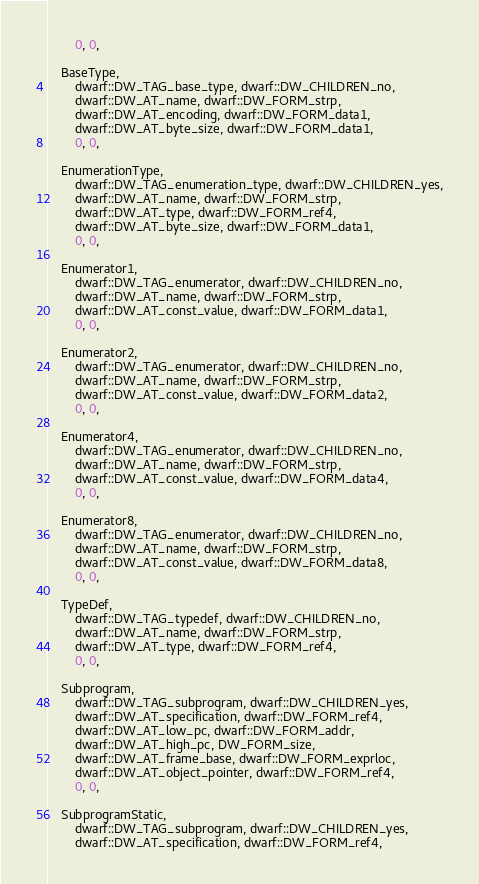<code> <loc_0><loc_0><loc_500><loc_500><_C++_>        0, 0,

    BaseType,
        dwarf::DW_TAG_base_type, dwarf::DW_CHILDREN_no,
        dwarf::DW_AT_name, dwarf::DW_FORM_strp,
        dwarf::DW_AT_encoding, dwarf::DW_FORM_data1,
        dwarf::DW_AT_byte_size, dwarf::DW_FORM_data1,
        0, 0,

    EnumerationType,
        dwarf::DW_TAG_enumeration_type, dwarf::DW_CHILDREN_yes,
        dwarf::DW_AT_name, dwarf::DW_FORM_strp,
        dwarf::DW_AT_type, dwarf::DW_FORM_ref4,
        dwarf::DW_AT_byte_size, dwarf::DW_FORM_data1,
        0, 0,

    Enumerator1,
        dwarf::DW_TAG_enumerator, dwarf::DW_CHILDREN_no,
        dwarf::DW_AT_name, dwarf::DW_FORM_strp,
        dwarf::DW_AT_const_value, dwarf::DW_FORM_data1,
        0, 0,

    Enumerator2,
        dwarf::DW_TAG_enumerator, dwarf::DW_CHILDREN_no,
        dwarf::DW_AT_name, dwarf::DW_FORM_strp,
        dwarf::DW_AT_const_value, dwarf::DW_FORM_data2,
        0, 0,

    Enumerator4,
        dwarf::DW_TAG_enumerator, dwarf::DW_CHILDREN_no,
        dwarf::DW_AT_name, dwarf::DW_FORM_strp,
        dwarf::DW_AT_const_value, dwarf::DW_FORM_data4,
        0, 0,

    Enumerator8,
        dwarf::DW_TAG_enumerator, dwarf::DW_CHILDREN_no,
        dwarf::DW_AT_name, dwarf::DW_FORM_strp,
        dwarf::DW_AT_const_value, dwarf::DW_FORM_data8,
        0, 0,

    TypeDef,
        dwarf::DW_TAG_typedef, dwarf::DW_CHILDREN_no,
        dwarf::DW_AT_name, dwarf::DW_FORM_strp,
        dwarf::DW_AT_type, dwarf::DW_FORM_ref4,
        0, 0,

    Subprogram,
        dwarf::DW_TAG_subprogram, dwarf::DW_CHILDREN_yes,
        dwarf::DW_AT_specification, dwarf::DW_FORM_ref4,
        dwarf::DW_AT_low_pc, dwarf::DW_FORM_addr,
        dwarf::DW_AT_high_pc, DW_FORM_size,
        dwarf::DW_AT_frame_base, dwarf::DW_FORM_exprloc,
        dwarf::DW_AT_object_pointer, dwarf::DW_FORM_ref4,
        0, 0,

    SubprogramStatic,
        dwarf::DW_TAG_subprogram, dwarf::DW_CHILDREN_yes,
        dwarf::DW_AT_specification, dwarf::DW_FORM_ref4,</code> 